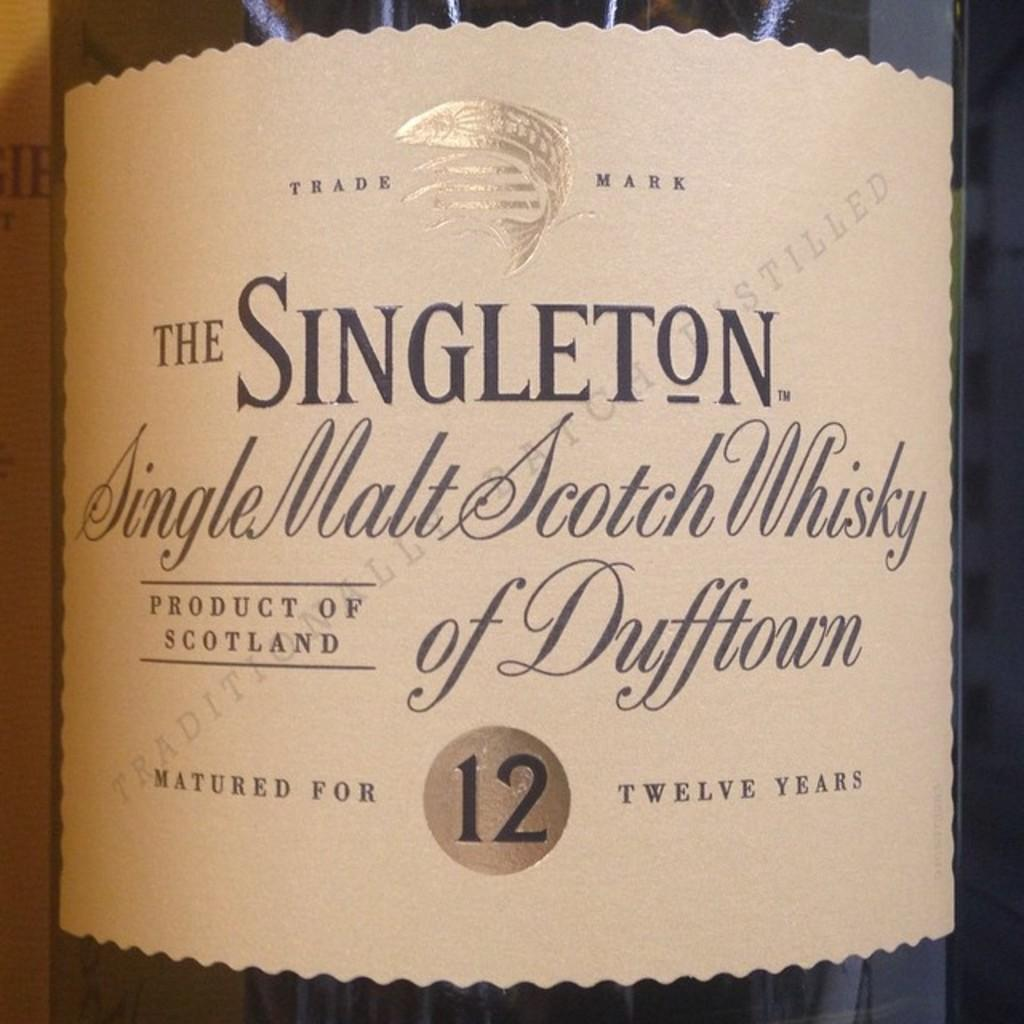<image>
Relay a brief, clear account of the picture shown. A closeup of label of The Singleton Single Malt Scotch Whisky of Dufftown 